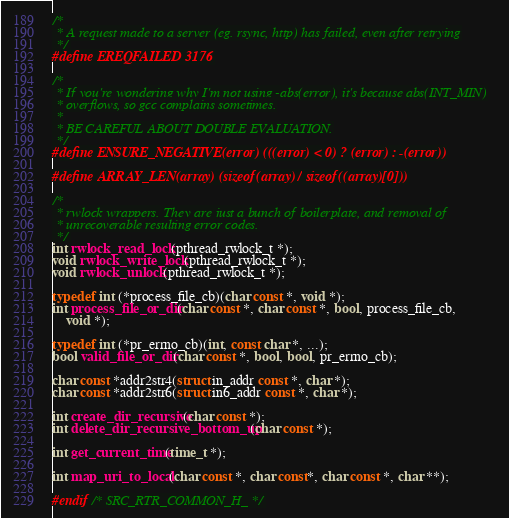Convert code to text. <code><loc_0><loc_0><loc_500><loc_500><_C_>
/*
 * A request made to a server (eg. rsync, http) has failed, even after retrying
 */
#define EREQFAILED 3176

/*
 * If you're wondering why I'm not using -abs(error), it's because abs(INT_MIN)
 * overflows, so gcc complains sometimes.
 *
 * BE CAREFUL ABOUT DOUBLE EVALUATION.
 */
#define ENSURE_NEGATIVE(error) (((error) < 0) ? (error) : -(error))

#define ARRAY_LEN(array) (sizeof(array) / sizeof((array)[0]))

/*
 * rwlock wrappers. They are just a bunch of boilerplate, and removal of
 * unrecoverable resulting error codes.
 */
int rwlock_read_lock(pthread_rwlock_t *);
void rwlock_write_lock(pthread_rwlock_t *);
void rwlock_unlock(pthread_rwlock_t *);

typedef int (*process_file_cb)(char const *, void *);
int process_file_or_dir(char const *, char const *, bool, process_file_cb,
    void *);

typedef int (*pr_errno_cb)(int, const char *, ...);
bool valid_file_or_dir(char const *, bool, bool, pr_errno_cb);

char const *addr2str4(struct in_addr const *, char *);
char const *addr2str6(struct in6_addr const *, char *);

int create_dir_recursive(char const *);
int delete_dir_recursive_bottom_up(char const *);

int get_current_time(time_t *);

int map_uri_to_local(char const *, char const*, char const *, char **);

#endif /* SRC_RTR_COMMON_H_ */
</code> 